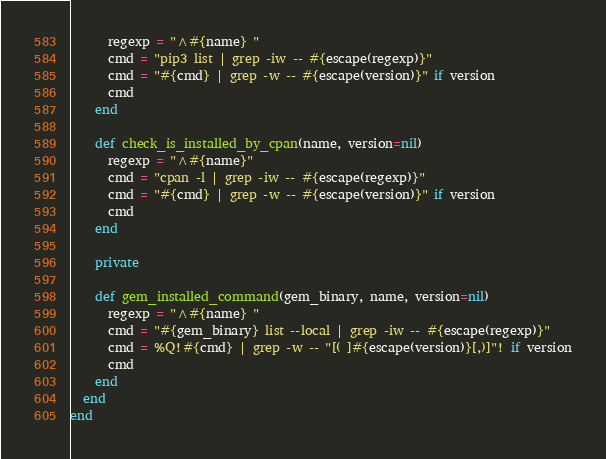Convert code to text. <code><loc_0><loc_0><loc_500><loc_500><_Ruby_>      regexp = "^#{name} "
      cmd = "pip3 list | grep -iw -- #{escape(regexp)}"
      cmd = "#{cmd} | grep -w -- #{escape(version)}" if version
      cmd
    end

    def check_is_installed_by_cpan(name, version=nil)
      regexp = "^#{name}"
      cmd = "cpan -l | grep -iw -- #{escape(regexp)}"
      cmd = "#{cmd} | grep -w -- #{escape(version)}" if version
      cmd
    end

    private

    def gem_installed_command(gem_binary, name, version=nil)
      regexp = "^#{name} "
      cmd = "#{gem_binary} list --local | grep -iw -- #{escape(regexp)}"
      cmd = %Q!#{cmd} | grep -w -- "[( ]#{escape(version)}[,)]"! if version
      cmd
    end
  end
end
</code> 